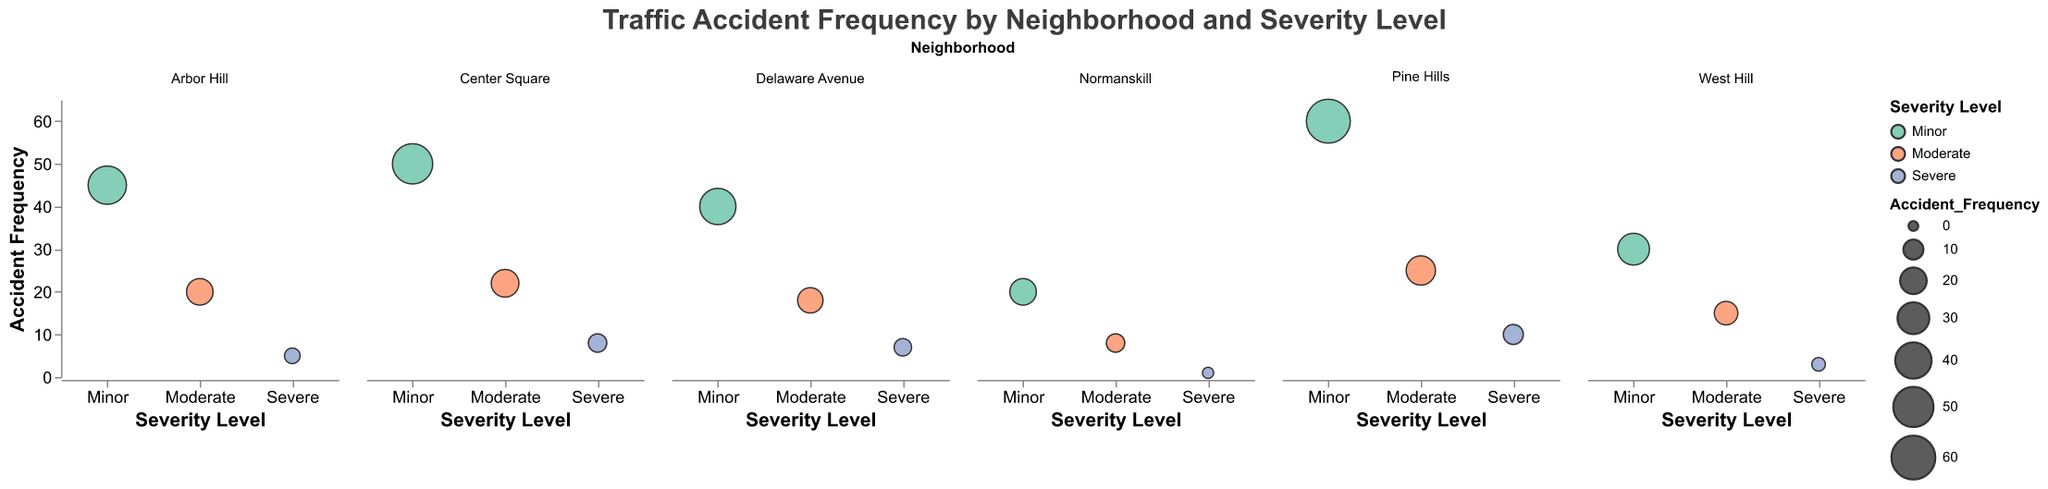what's the title of the chart? The title of the chart is typically displayed at the top. In this case, it reads "Traffic Accident Frequency by Neighborhood and Severity Level"
Answer: "Traffic Accident Frequency by Neighborhood and Severity Level" what do the colors represent? The colors represent different severity levels of traffic accidents: greenish color for Minor, orange for Moderate, and bluish for Severe. This can be determined by looking at the legend.
Answer: Severity levels What's the highest accident frequency in Pine Hills? For Pine Hills, the bubble with the largest size under the "Minor" severity level has an accident frequency of 60.
Answer: 60 how does the accident frequency for severe accidents in Delaware Avenue compare to that in Normanskill? To compare, we look at the bubbles corresponding to severe accidents in Delaware Avenue and Normanskill. Delaware Avenue has a frequency of 7, while Normanskill has a frequency of 1.
Answer: Delaware Avenue has more severe accidents than Normanskill which neighborhood has the lowest number of severe accidents? The neighborhood with the smallest bubble corresponding to severe accidents will have the lowest number. Normanskill has the smallest bubble with a frequency of 1.
Answer: Normanskill what's the sum of minor and moderate accident frequencies in Arbor Hill? Summing the frequencies: 45 for Minor and 20 for Moderate gives a total of 45 + 20 = 65.
Answer: 65 which neighborhood shows the highest variety in accident frequencies across different severity levels? Looking at the range of bubble sizes for each severity level per neighborhood, Pine Hills has the highest variety with frequencies of 60 (Minor), 25 (Moderate), and 10 (Severe).
Answer: Pine Hills what's common in accident frequencies between Center Square and Delaware Avenue for severe accidents? Both neighborhoods have bubbles under the "Severe" category. Center Square has 8, and Delaware Avenue has 7.
Answer: They both have high severe accident frequencies compared to Normanskill how do the frequencies of moderate accidents in Pine Hills compare to those in West Hill? Pine Hills has a frequency of 25 for moderate accidents, whereas West Hill has 15. Therefore, Pine Hills has more moderate accidents.
Answer: Pine Hills has higher moderate accident frequency than West Hill which neighborhood has the most minor accidents? The largest bubble under the "Minor" category indicates the highest frequency. Pine Hills has the largest bubble with a frequency of 60.
Answer: Pine Hills 